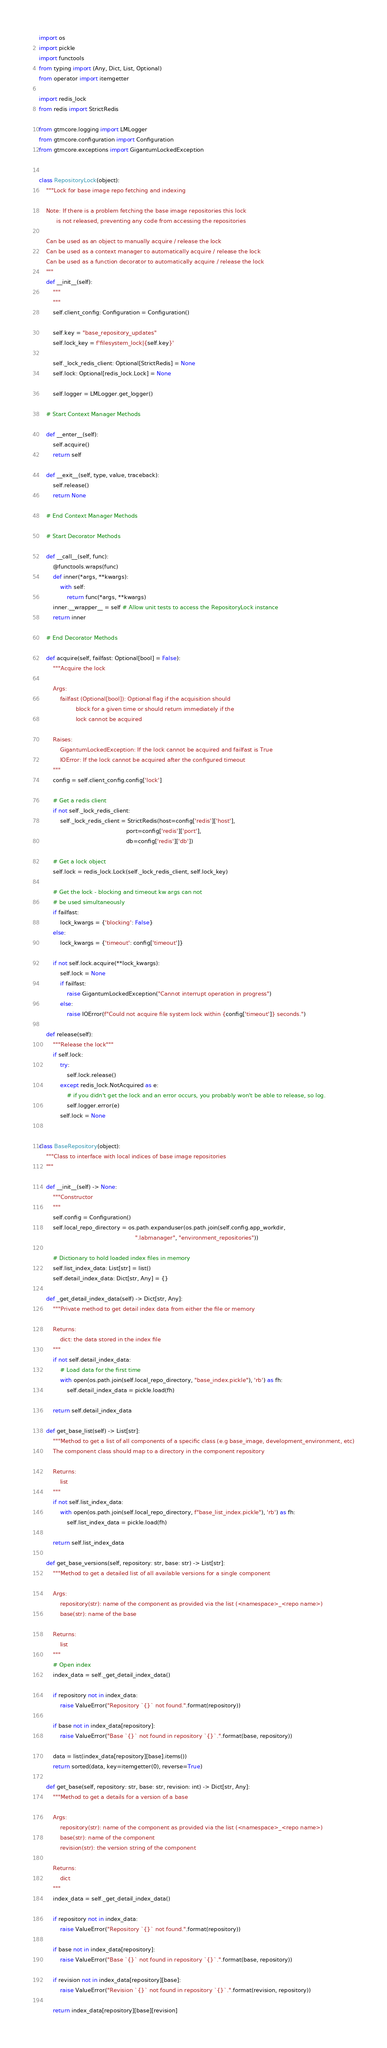<code> <loc_0><loc_0><loc_500><loc_500><_Python_>import os
import pickle
import functools
from typing import (Any, Dict, List, Optional)
from operator import itemgetter

import redis_lock
from redis import StrictRedis

from gtmcore.logging import LMLogger
from gtmcore.configuration import Configuration
from gtmcore.exceptions import GigantumLockedException


class RepositoryLock(object):
    """Lock for base image repo fetching and indexing

    Note: If there is a problem fetching the base image repositories this lock
          is not released, preventing any code from accessing the repositories

    Can be used as an object to manually acquire / release the lock
    Can be used as a context manager to automatically acquire / release the lock
    Can be used as a function decorator to automatically acquire / release the lock
    """
    def __init__(self):
        """
        """
        self.client_config: Configuration = Configuration()

        self.key = "base_repository_updates"
        self.lock_key = f'filesystem_lock|{self.key}'

        self._lock_redis_client: Optional[StrictRedis] = None
        self.lock: Optional[redis_lock.Lock] = None

        self.logger = LMLogger.get_logger()

    # Start Context Manager Methods

    def __enter__(self):
        self.acquire()
        return self

    def __exit__(self, type, value, traceback):
        self.release()
        return None

    # End Context Manager Methods

    # Start Decorator Methods

    def __call__(self, func):
        @functools.wraps(func)
        def inner(*args, **kwargs):
            with self:
                return func(*args, **kwargs)
        inner.__wrapper__ = self # Allow unit tests to access the RepositoryLock instance
        return inner

    # End Decorator Methods

    def acquire(self, failfast: Optional[bool] = False):
        """Acquire the lock

        Args:
            failfast (Optional[bool]): Optional flag if the acquisition should
                     block for a given time or should return immediately if the
                     lock cannot be acquired

        Raises:
            GigantumLockedException: If the lock cannot be acquired and failfast is True
            IOError: If the lock cannot be acquired after the configured timeout
        """
        config = self.client_config.config['lock']

        # Get a redis client
        if not self._lock_redis_client:
            self._lock_redis_client = StrictRedis(host=config['redis']['host'],
                                                  port=config['redis']['port'],
                                                  db=config['redis']['db'])

        # Get a lock object
        self.lock = redis_lock.Lock(self._lock_redis_client, self.lock_key)

        # Get the lock - blocking and timeout kw args can not
        # be used simultaneously
        if failfast:
            lock_kwargs = {'blocking': False}
        else:
            lock_kwargs = {'timeout': config['timeout']}

        if not self.lock.acquire(**lock_kwargs):
            self.lock = None
            if failfast:
                raise GigantumLockedException("Cannot interrupt operation in progress")
            else:
                raise IOError(f"Could not acquire file system lock within {config['timeout']} seconds.")

    def release(self):
        """Release the lock"""
        if self.lock:
            try:
                self.lock.release()
            except redis_lock.NotAcquired as e:
                # if you didn't get the lock and an error occurs, you probably won't be able to release, so log.
                self.logger.error(e)
            self.lock = None


class BaseRepository(object):
    """Class to interface with local indices of base image repositories
    """

    def __init__(self) -> None:
        """Constructor
        """
        self.config = Configuration()
        self.local_repo_directory = os.path.expanduser(os.path.join(self.config.app_workdir,
                                                       ".labmanager", "environment_repositories"))

        # Dictionary to hold loaded index files in memory
        self.list_index_data: List[str] = list()
        self.detail_index_data: Dict[str, Any] = {}

    def _get_detail_index_data(self) -> Dict[str, Any]:
        """Private method to get detail index data from either the file or memory

        Returns:
            dict: the data stored in the index file
        """
        if not self.detail_index_data:
            # Load data for the first time
            with open(os.path.join(self.local_repo_directory, "base_index.pickle"), 'rb') as fh:
                self.detail_index_data = pickle.load(fh)

        return self.detail_index_data

    def get_base_list(self) -> List[str]:
        """Method to get a list of all components of a specific class (e.g base_image, development_environment, etc)
        The component class should map to a directory in the component repository

        Returns:
            list
        """
        if not self.list_index_data:
            with open(os.path.join(self.local_repo_directory, f"base_list_index.pickle"), 'rb') as fh:
                self.list_index_data = pickle.load(fh)

        return self.list_index_data

    def get_base_versions(self, repository: str, base: str) -> List[str]:
        """Method to get a detailed list of all available versions for a single component

        Args:
            repository(str): name of the component as provided via the list (<namespace>_<repo name>)
            base(str): name of the base

        Returns:
            list
        """
        # Open index
        index_data = self._get_detail_index_data()

        if repository not in index_data:
            raise ValueError("Repository `{}` not found.".format(repository))

        if base not in index_data[repository]:
            raise ValueError("Base `{}` not found in repository `{}`.".format(base, repository))

        data = list(index_data[repository][base].items())
        return sorted(data, key=itemgetter(0), reverse=True)

    def get_base(self, repository: str, base: str, revision: int) -> Dict[str, Any]:
        """Method to get a details for a version of a base

        Args:
            repository(str): name of the component as provided via the list (<namespace>_<repo name>)
            base(str): name of the component
            revision(str): the version string of the component

        Returns:
            dict
        """
        index_data = self._get_detail_index_data()

        if repository not in index_data:
            raise ValueError("Repository `{}` not found.".format(repository))

        if base not in index_data[repository]:
            raise ValueError("Base `{}` not found in repository `{}`.".format(base, repository))

        if revision not in index_data[repository][base]:
            raise ValueError("Revision `{}` not found in repository `{}`.".format(revision, repository))

        return index_data[repository][base][revision]
</code> 